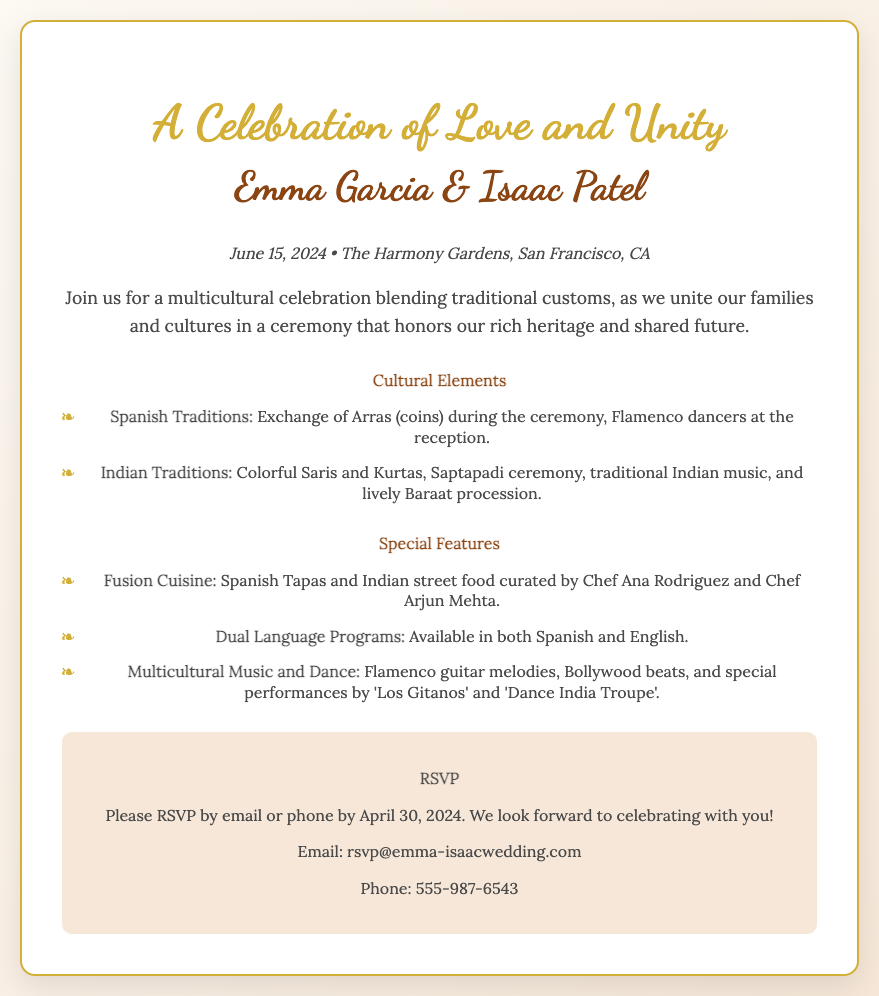What is the date of the wedding? The date of the wedding is stated in the document as June 15, 2024.
Answer: June 15, 2024 Who are the couple getting married? The document introduces the couple as Emma Garcia and Isaac Patel.
Answer: Emma Garcia & Isaac Patel Where is the wedding taking place? The wedding location is mentioned in the document as The Harmony Gardens, San Francisco, CA.
Answer: The Harmony Gardens, San Francisco, CA What is a featured Spanish tradition? The document lists the Exchange of Arras as a specific Spanish tradition during the ceremony.
Answer: Exchange of Arras What type of cuisine will be served? The invitation mentions that Spanish Tapas and Indian street food will be part of the cuisine offered at the wedding.
Answer: Fusion Cuisine When is the RSVP deadline? The deadline for RSVP is specified as April 30, 2024.
Answer: April 30, 2024 What music genres will be featured at the wedding? The document states that Flamenco guitar melodies and Bollywood beats will be included in the musical performances.
Answer: Flamenco guitar melodies, Bollywood beats How should guests confirm their attendance? The RSVP section indicates that guests should confirm by email or phone.
Answer: Email or phone What is a unique feature of the wedding program? The wedding program will be available in both Spanish and English, as mentioned in the special features section.
Answer: Dual Language Programs 